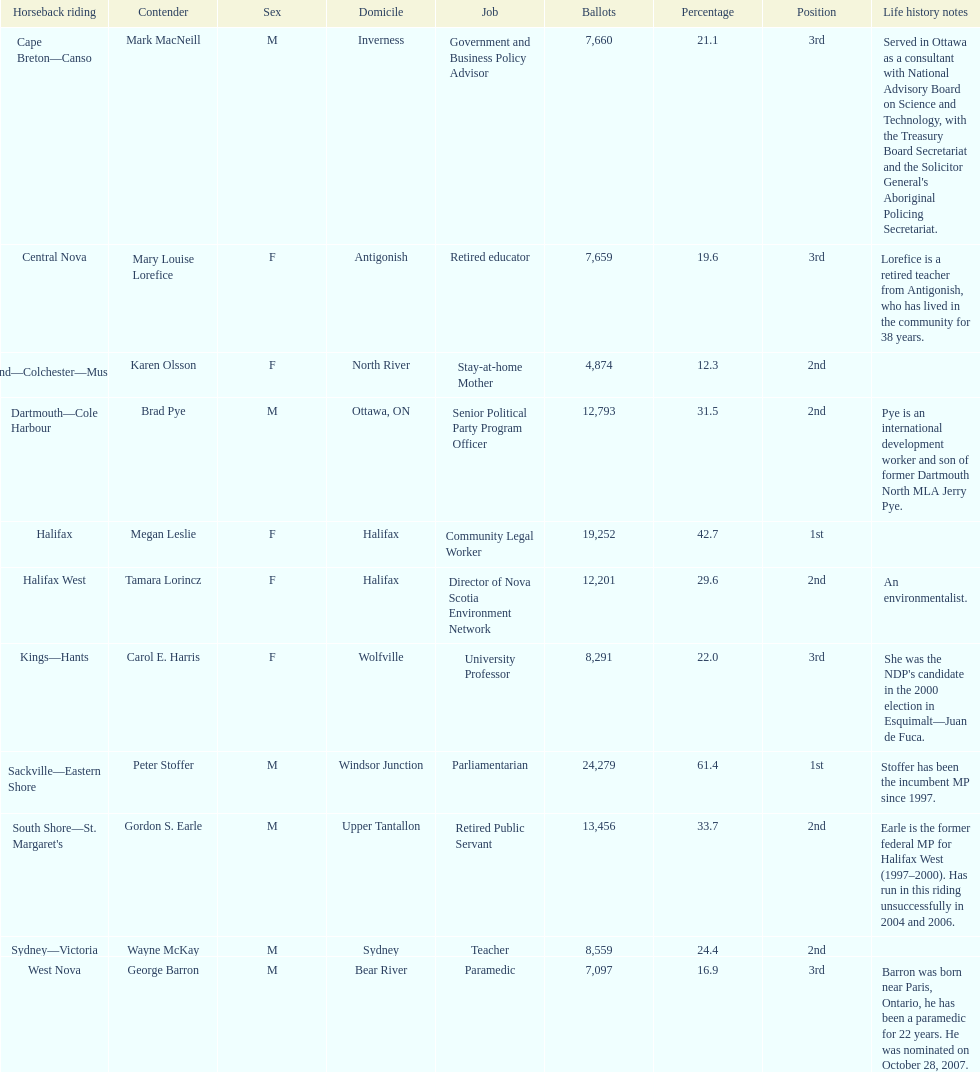How many contenders received more votes than tamara lorincz? 4. 